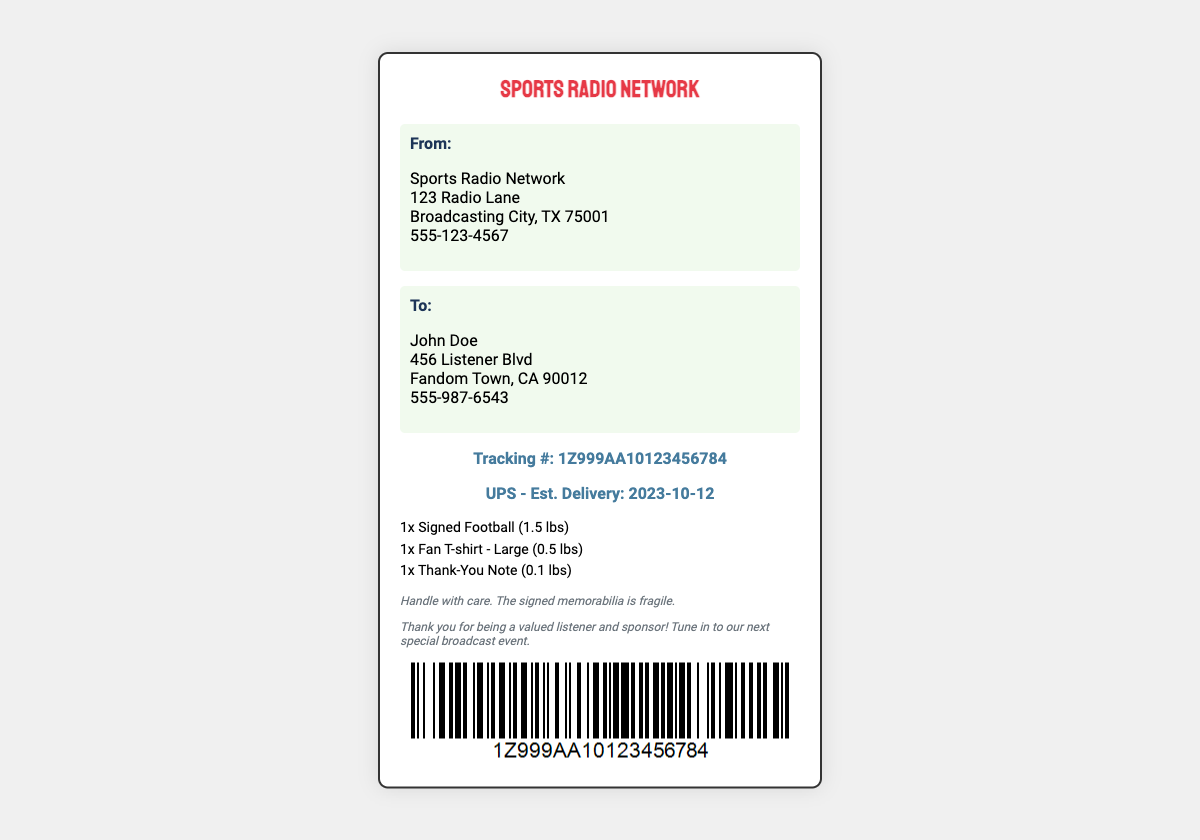What is the sender's address? The sender's address is mentioned under "From:" in the document, listing Sports Radio Network and the full address.
Answer: Sports Radio Network, 123 Radio Lane, Broadcasting City, TX 75001 Who is the recipient? The recipient's name is stated under "To:" in the document, detailing the full name of the individual addressed.
Answer: John Doe What items are included in the shipment? The items are listed in the "items" section of the document, detailing what is being shipped.
Answer: Signed Football, Fan T-shirt - Large, Thank-You Note What is the estimated delivery date? The estimated delivery date is mentioned in the tracking section, indicating when the package is expected to arrive.
Answer: 2023-10-12 What is the tracking number? The tracking number is specifically noted in the tracking section of the document, allowing for package tracking.
Answer: 1Z999AA10123456784 What should be used to handle the signed memorabilia? The document includes a note on how to treat the fragile signed memorabilia safely.
Answer: Handle with care How much does the signed football weigh? The weight of the signed football is specified next to the item in the "items" section.
Answer: 1.5 lbs What type of merchandise is being sent to the listeners? The type of merchandise is indicated through the items listed in the document, specifying what is included in the shipment.
Answer: Signed memorabilia, fan merchandise What color is the Sports Radio Network logo? The logo color is described indirectly through the document's design and branding elements.
Answer: Red 